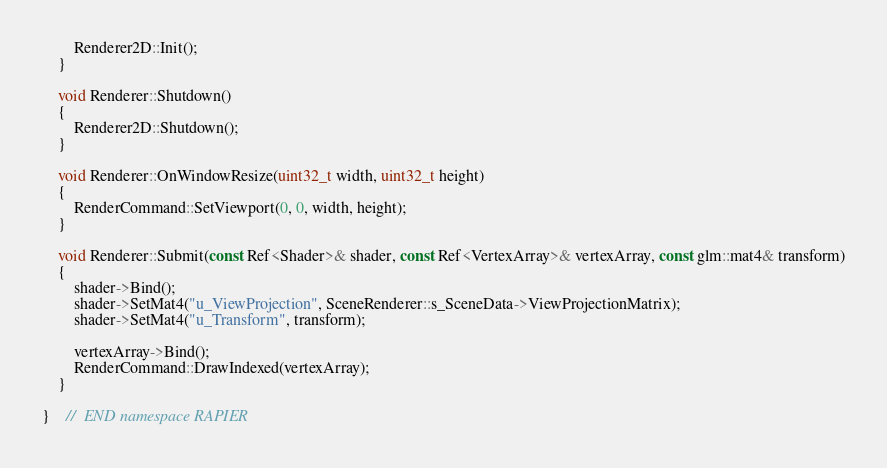Convert code to text. <code><loc_0><loc_0><loc_500><loc_500><_C++_>		Renderer2D::Init();
	}

	void Renderer::Shutdown()
	{
		Renderer2D::Shutdown();
	}

	void Renderer::OnWindowResize(uint32_t width, uint32_t height)
	{
		RenderCommand::SetViewport(0, 0, width, height);
	}

	void Renderer::Submit(const Ref<Shader>& shader, const Ref<VertexArray>& vertexArray, const glm::mat4& transform)
	{
		shader->Bind();
		shader->SetMat4("u_ViewProjection", SceneRenderer::s_SceneData->ViewProjectionMatrix);
		shader->SetMat4("u_Transform", transform);

		vertexArray->Bind();
		RenderCommand::DrawIndexed(vertexArray);
	}

}	//	END namespace RAPIER
</code> 